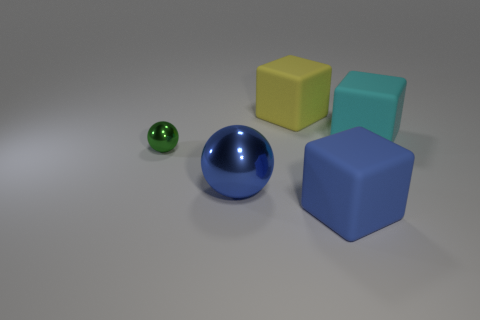Add 1 small gray matte balls. How many objects exist? 6 Subtract all blocks. How many objects are left? 2 Subtract 0 purple spheres. How many objects are left? 5 Subtract all tiny balls. Subtract all yellow cubes. How many objects are left? 3 Add 5 blue matte things. How many blue matte things are left? 6 Add 3 big yellow cubes. How many big yellow cubes exist? 4 